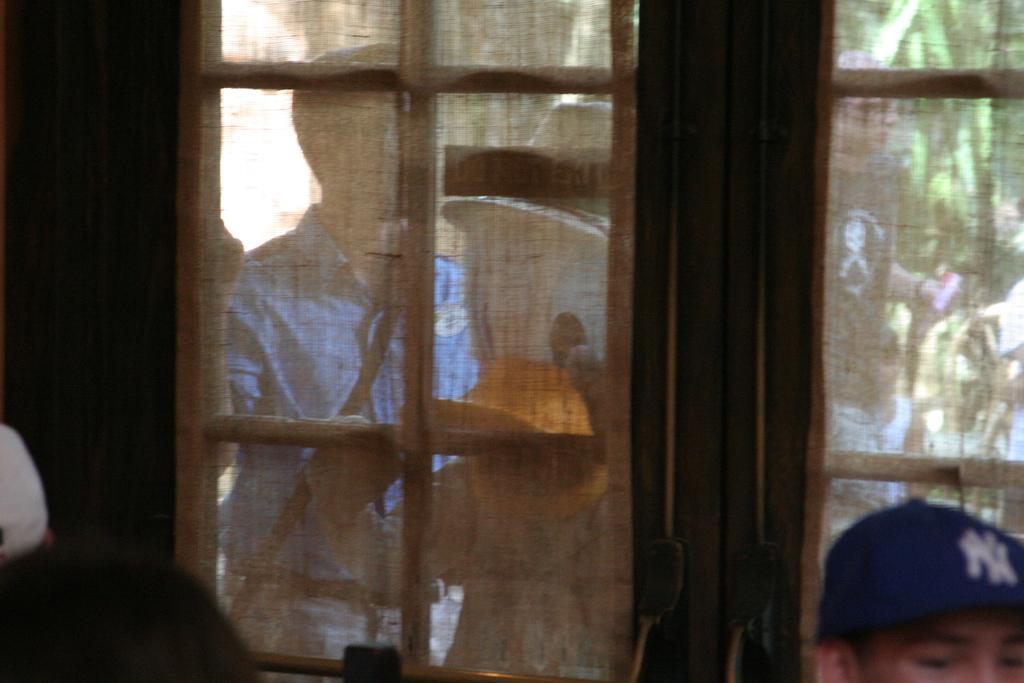How would you summarize this image in a sentence or two? This picture is clicked inside. In the foreground we can see the door and a person standing on the ground. In the background we can see the tree, persons and some other objects. 